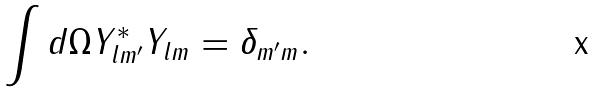<formula> <loc_0><loc_0><loc_500><loc_500>\int d \Omega Y ^ { * } _ { l m ^ { \prime } } Y _ { l m } = \delta _ { m ^ { \prime } m } .</formula> 